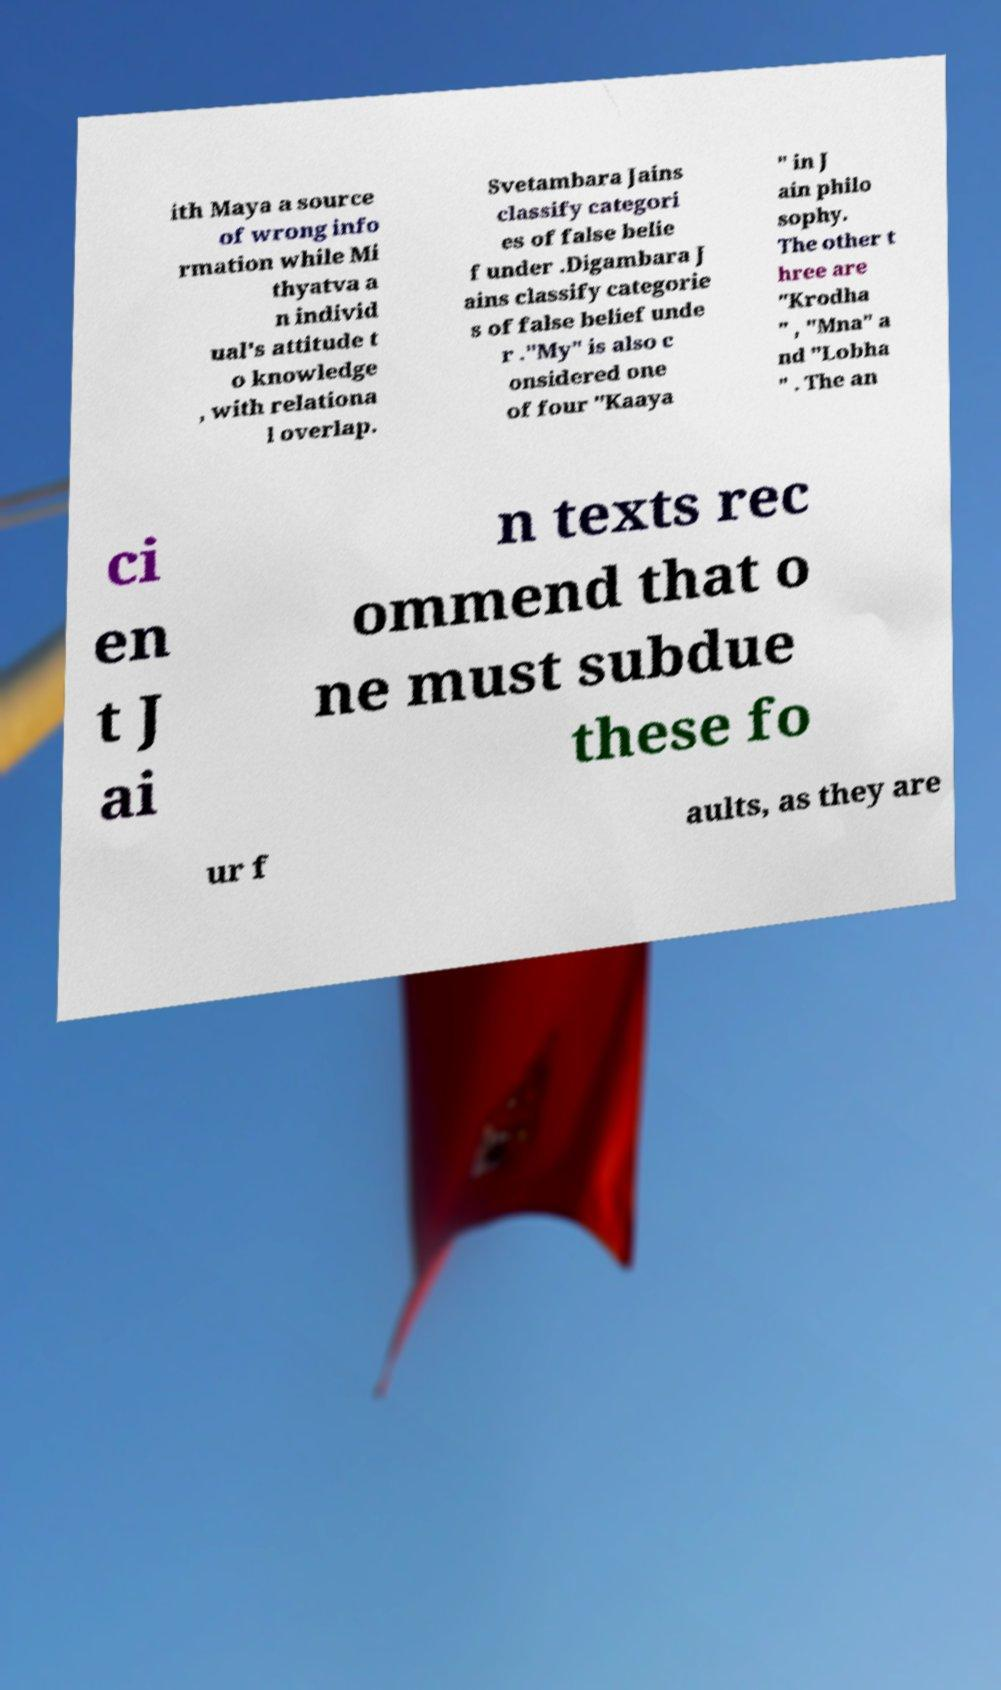Can you accurately transcribe the text from the provided image for me? ith Maya a source of wrong info rmation while Mi thyatva a n individ ual's attitude t o knowledge , with relationa l overlap. Svetambara Jains classify categori es of false belie f under .Digambara J ains classify categorie s of false belief unde r ."My" is also c onsidered one of four "Kaaya " in J ain philo sophy. The other t hree are "Krodha " , "Mna" a nd "Lobha " . The an ci en t J ai n texts rec ommend that o ne must subdue these fo ur f aults, as they are 